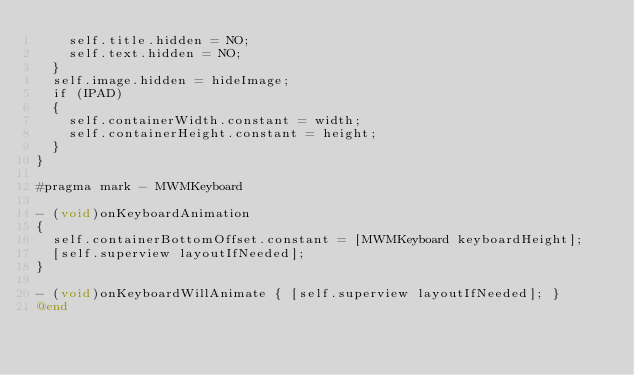<code> <loc_0><loc_0><loc_500><loc_500><_ObjectiveC_>    self.title.hidden = NO;
    self.text.hidden = NO;
  }
  self.image.hidden = hideImage;
  if (IPAD)
  {
    self.containerWidth.constant = width;
    self.containerHeight.constant = height;
  }
}

#pragma mark - MWMKeyboard

- (void)onKeyboardAnimation
{
  self.containerBottomOffset.constant = [MWMKeyboard keyboardHeight];
  [self.superview layoutIfNeeded];
}

- (void)onKeyboardWillAnimate { [self.superview layoutIfNeeded]; }
@end
</code> 